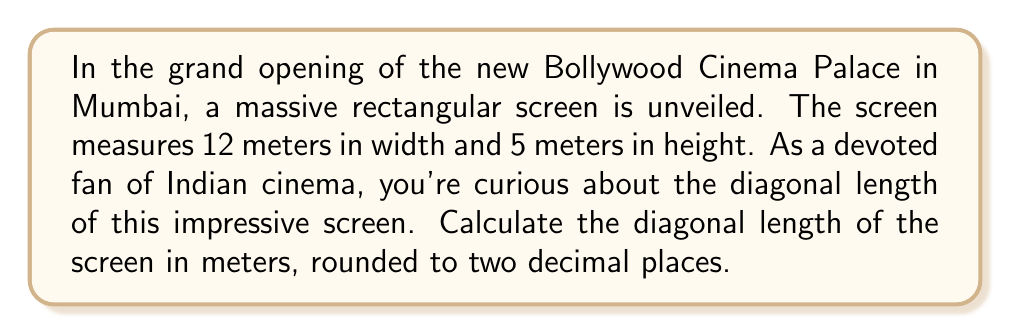Can you solve this math problem? To find the diagonal length of the rectangular movie screen, we can use the Pythagorean theorem. Let's approach this step-by-step:

1) Let's denote the width as $w$, height as $h$, and diagonal as $d$.

2) According to the Pythagorean theorem:
   $$d^2 = w^2 + h^2$$

3) We know that $w = 12$ meters and $h = 5$ meters. Let's substitute these values:
   $$d^2 = 12^2 + 5^2$$

4) Now, let's calculate:
   $$d^2 = 144 + 25 = 169$$

5) To find $d$, we need to take the square root of both sides:
   $$d = \sqrt{169}$$

6) Simplifying:
   $$d = 13$$

7) The question asks for the answer rounded to two decimal places, so our final answer is 13.00 meters.

[asy]
unitsize(10mm);
draw((0,0)--(12,0)--(12,5)--(0,5)--cycle);
draw((0,0)--(12,5),dashed);
label("12 m", (6,0), S);
label("5 m", (12,2.5), E);
label("13 m", (6,2.5), NW);
[/asy]
Answer: 13.00 meters 